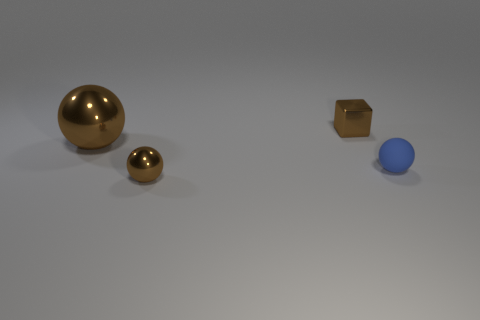Add 2 small brown shiny balls. How many objects exist? 6 Subtract all blocks. How many objects are left? 3 Add 4 blue matte things. How many blue matte things exist? 5 Subtract 1 brown cubes. How many objects are left? 3 Subtract all brown spheres. Subtract all big things. How many objects are left? 1 Add 2 brown spheres. How many brown spheres are left? 4 